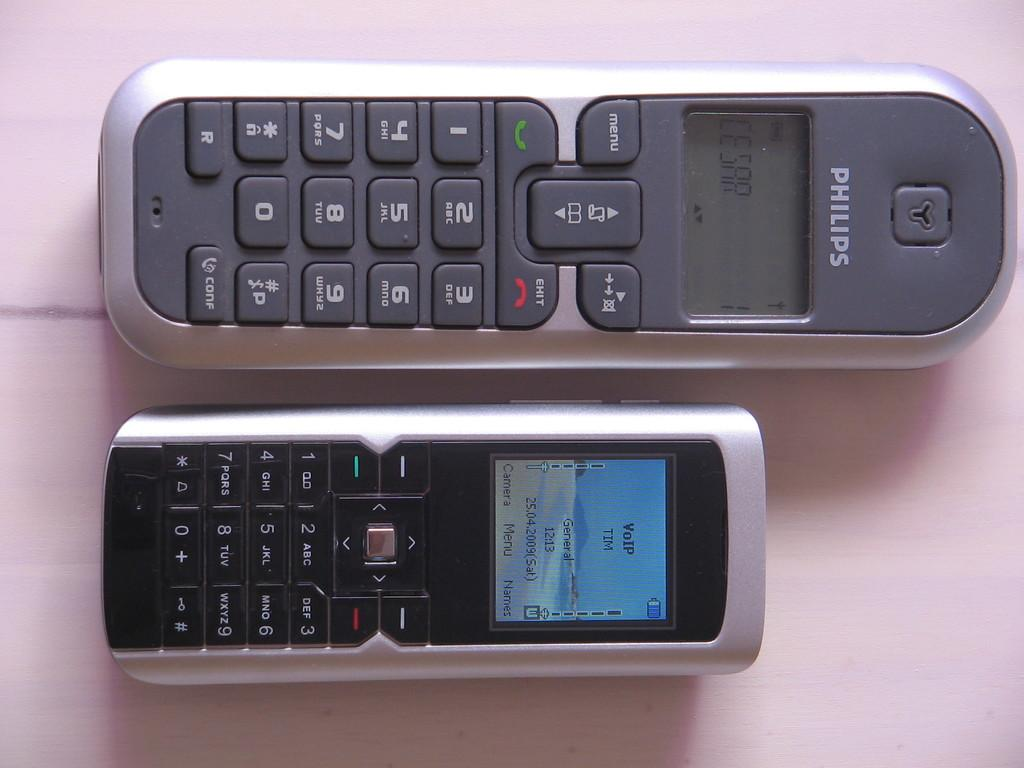<image>
Summarize the visual content of the image. two old cellphones, one a philips the other without a brand 